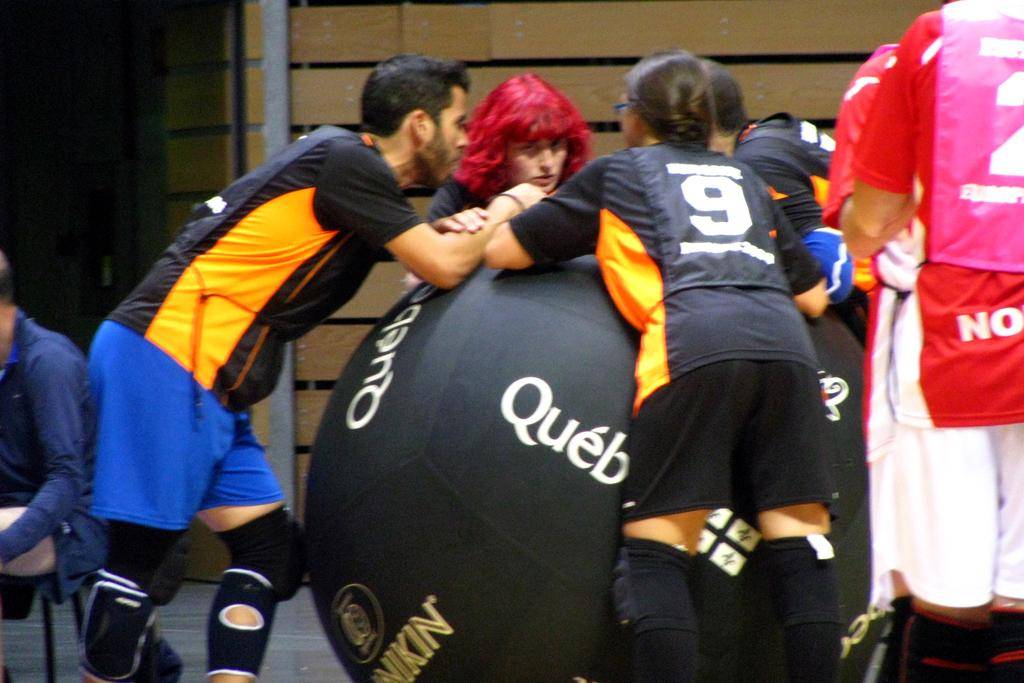What can be seen in the image involving people? There are players in the image. What is written or displayed on the black color wall? There is text on a black color wall in the image. What is also present on the black color wall? There is a logo on the black color wall. What can be seen in the background of the image? Walls and a pole are visible in the background of the image. What is the surface that the players and the wall are on? The surface is visible in the image. Can you tell me how many bears are standing next to the players in the image? There are no bears present in the image. What advice does the mom give to the players in the image? There is no mom present in the image, and therefore no advice can be given. 